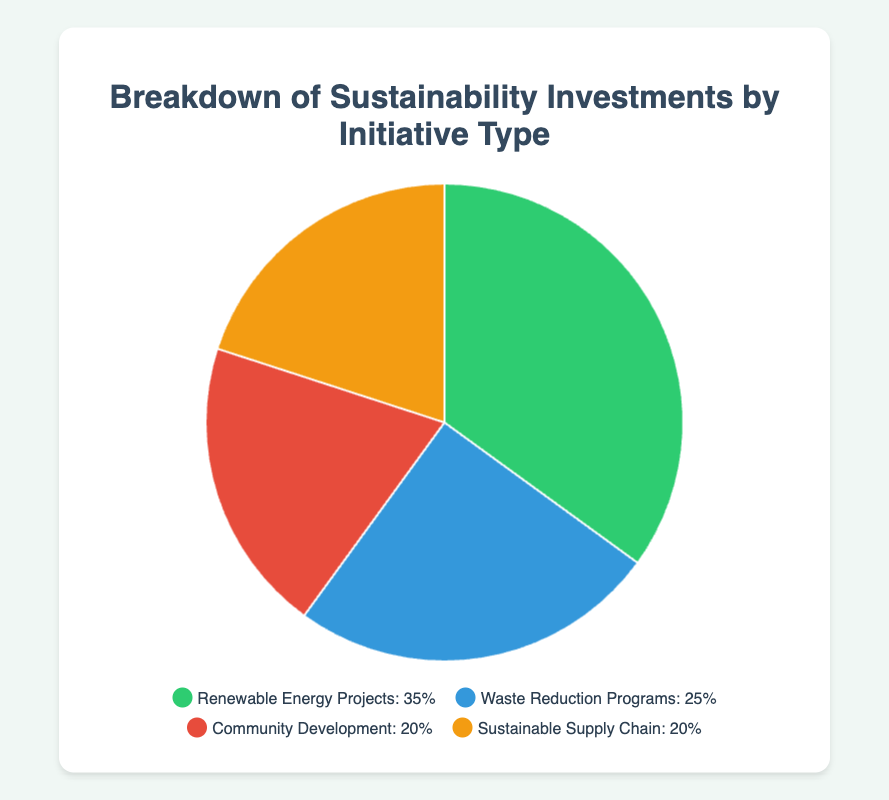What percentage of the total investment is allocated to Renewable Energy Projects and Waste Reduction Programs combined? Add the percentage for Renewable Energy Projects (35%) and Waste Reduction Programs (25%). 35% + 25% = 60%
Answer: 60% Which initiative type has the lowest investment percentage? The pie chart shows four initiative types with their respective percentages. Both Community Development and Sustainable Supply Chain tie for the lowest at 20% each.
Answer: Community Development and Sustainable Supply Chain How much more is invested in Renewable Energy Projects compared to Community Development? Subtract the percentage for Community Development (20%) from that for Renewable Energy Projects (35%). 35% - 20% = 15%
Answer: 15% Which initiative types have an equal share of the investments? Look at the percentages; both Community Development and Sustainable Supply Chain have 20% each.
Answer: Community Development and Sustainable Supply Chain What color represents the Waste Reduction Programs in the pie chart? The legend next to the pie chart shows colors associated with each initiative type. Waste Reduction Programs are highlighted in blue.
Answer: Blue Is the investment in Renewable Energy Projects more than twice the investment in Community Development? Double the investment in Community Development (20% * 2 = 40%). Compare this to the investment in Renewable Energy Projects (35%), which is less than 40%.
Answer: No How does the sum of investments in Community Development and Sustainable Supply Chain compare to the investment in Renewable Energy Projects? Add the percentages for Community Development and Sustainable Supply Chain (20% + 20% = 40%). Compare this to the percentage for Renewable Energy Projects (35%). 40% > 35%
Answer: The sum is greater If the Waste Reduction Programs' investment were increased by 5%, what would its percentage be? Add 5% to the current investment percentage for Waste Reduction Programs (25%). 25% + 5% = 30%
Answer: 30% What is the combined investment percentage for the two initiative types with the highest investments? Add the percentages for Renewable Energy Projects (35%) and Waste Reduction Programs (25%). 35% + 25% = 60%
Answer: 60% If we wanted to increase all investment percentages equally such that their total sums to 120%, by what percentage would each initiative type increase? The current total is 35% + 25% + 20% + 20% = 100%. We need to raise the total to 120%, so each type's percentage can increase by (120% - 100%) / 4 = 5%.
Answer: 5% 